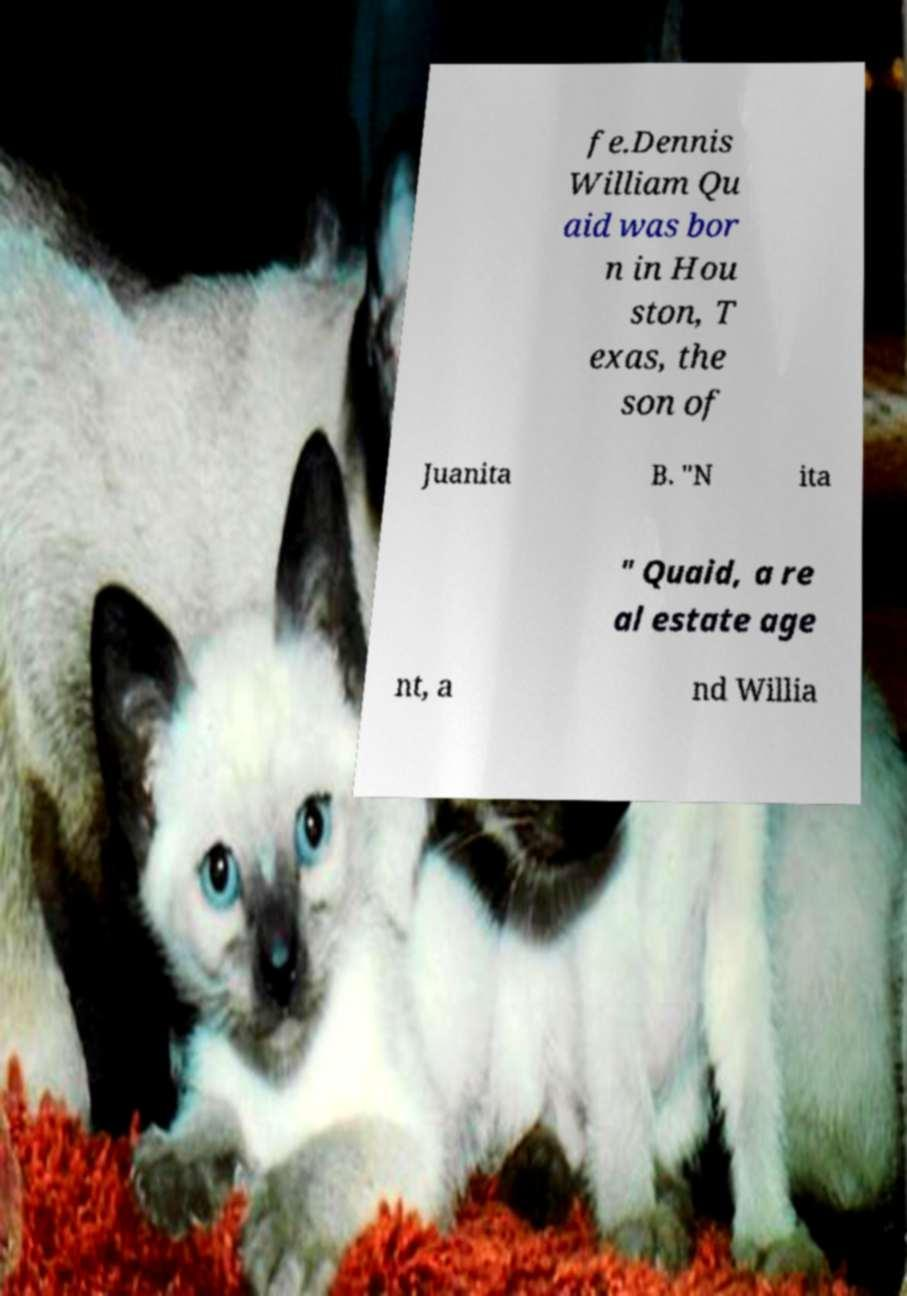Could you assist in decoding the text presented in this image and type it out clearly? fe.Dennis William Qu aid was bor n in Hou ston, T exas, the son of Juanita B. "N ita " Quaid, a re al estate age nt, a nd Willia 